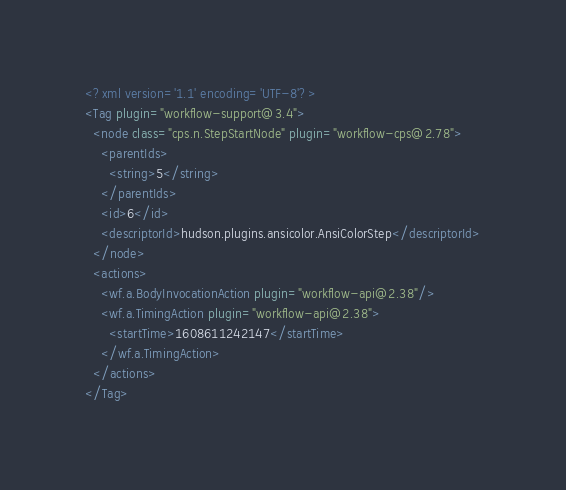<code> <loc_0><loc_0><loc_500><loc_500><_XML_><?xml version='1.1' encoding='UTF-8'?>
<Tag plugin="workflow-support@3.4">
  <node class="cps.n.StepStartNode" plugin="workflow-cps@2.78">
    <parentIds>
      <string>5</string>
    </parentIds>
    <id>6</id>
    <descriptorId>hudson.plugins.ansicolor.AnsiColorStep</descriptorId>
  </node>
  <actions>
    <wf.a.BodyInvocationAction plugin="workflow-api@2.38"/>
    <wf.a.TimingAction plugin="workflow-api@2.38">
      <startTime>1608611242147</startTime>
    </wf.a.TimingAction>
  </actions>
</Tag></code> 